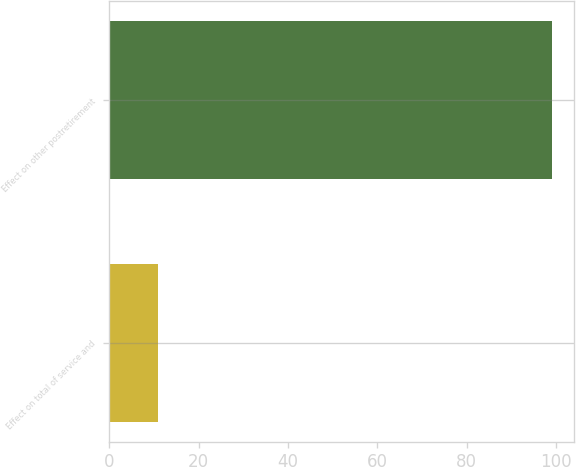<chart> <loc_0><loc_0><loc_500><loc_500><bar_chart><fcel>Effect on total of service and<fcel>Effect on other postretirement<nl><fcel>11<fcel>99<nl></chart> 